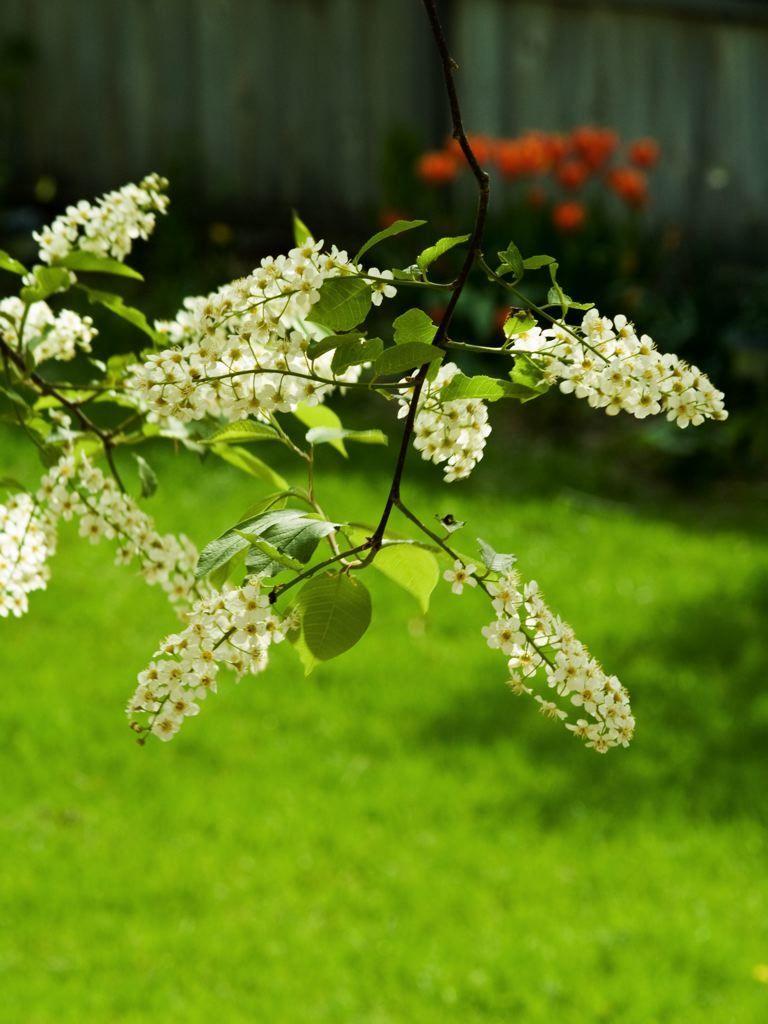Could you give a brief overview of what you see in this image? There are some flowers with leaves and a stem at the middle of this image and there is a grassy land at the bottom of this image. It seems like there is a wall in the background. 